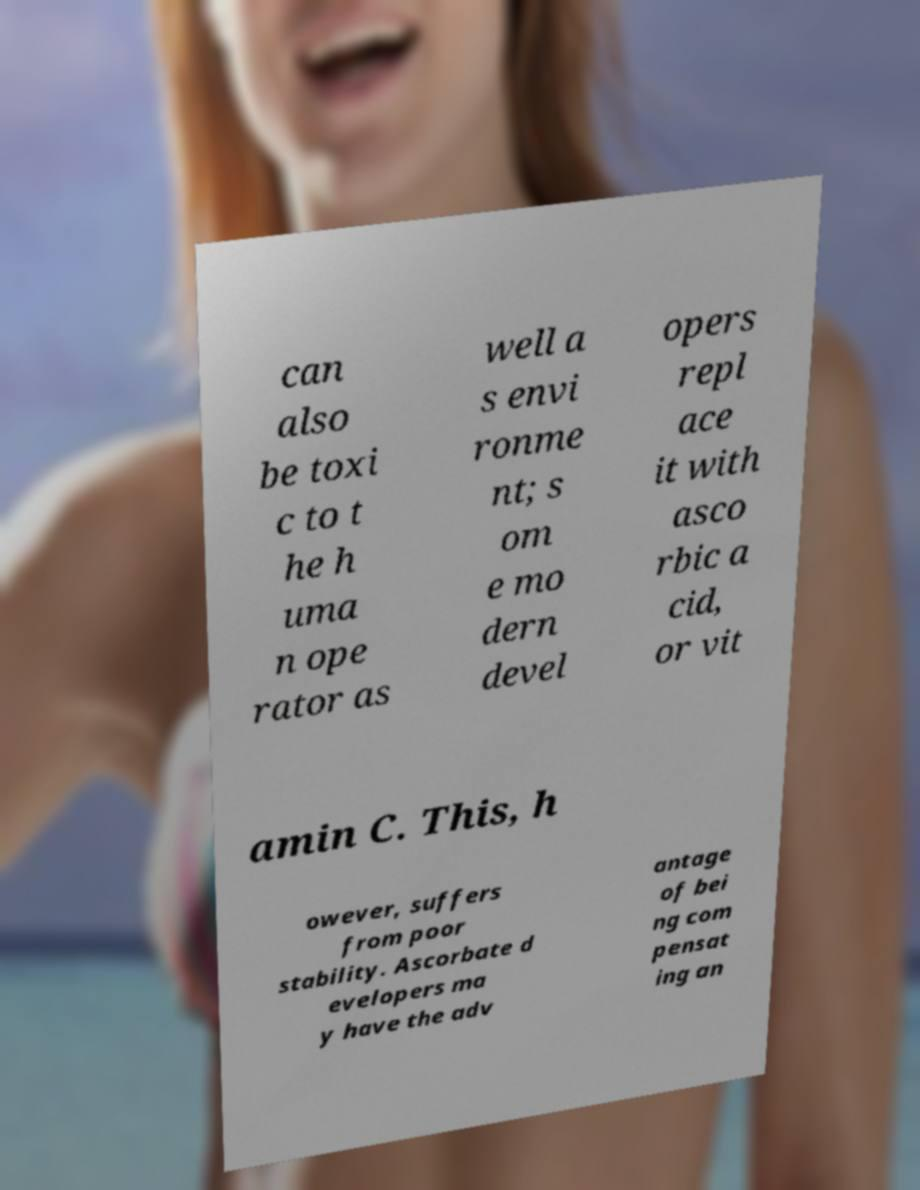Could you extract and type out the text from this image? can also be toxi c to t he h uma n ope rator as well a s envi ronme nt; s om e mo dern devel opers repl ace it with asco rbic a cid, or vit amin C. This, h owever, suffers from poor stability. Ascorbate d evelopers ma y have the adv antage of bei ng com pensat ing an 